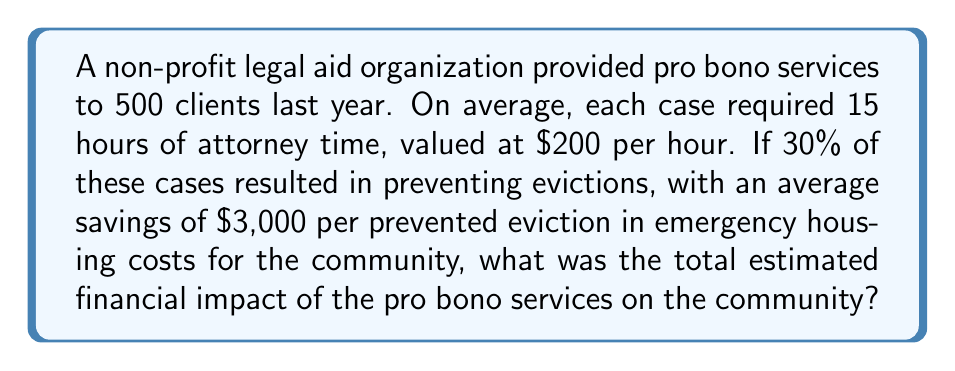Solve this math problem. Let's break this down step-by-step:

1. Calculate the value of attorney time:
   - Number of clients: 500
   - Hours per case: 15
   - Value per hour: $200
   Total value = $500 \times 15 \times $200 = $1,500,000

2. Calculate the number of evictions prevented:
   - 30% of 500 cases = $500 \times 0.30 = 150$ cases

3. Calculate the savings from prevented evictions:
   - Number of prevented evictions: 150
   - Savings per prevention: $3,000
   Total savings = $150 \times $3,000 = $450,000

4. Sum up the total financial impact:
   Total impact = Value of attorney time + Savings from prevented evictions
   $$ \text{Total impact} = $1,500,000 + $450,000 = $1,950,000 $$

Therefore, the total estimated financial impact of the pro bono services on the community is $1,950,000.
Answer: $1,950,000 